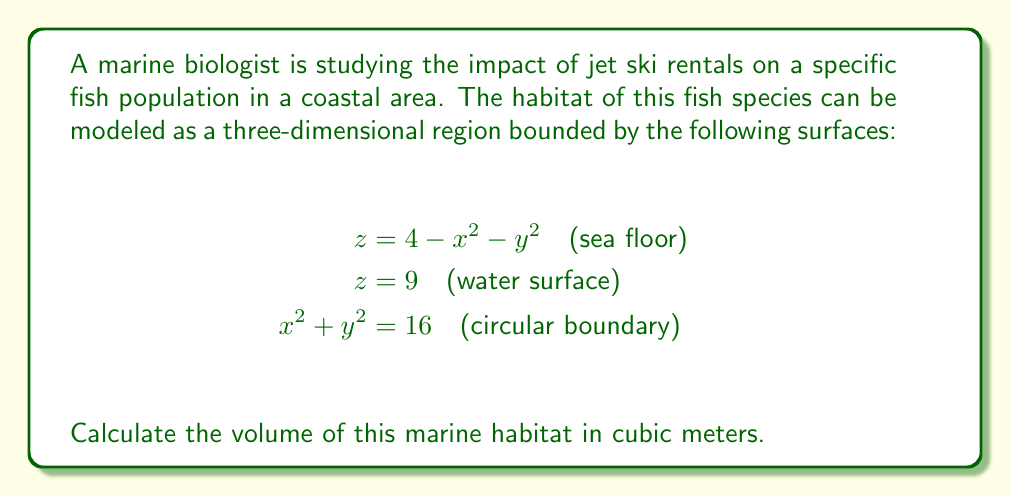Teach me how to tackle this problem. To determine the volume of this three-dimensional marine habitat, we need to set up and evaluate a triple integral. Let's approach this step-by-step:

1) First, we need to determine the limits of integration. From the given equations:
   - The habitat is bounded from below by $z = 4 - x^2 - y^2$ and from above by $z = 9$.
   - The circular boundary $x^2 + y^2 = 16$ suggests we should use cylindrical coordinates.

2) In cylindrical coordinates, we have:
   $x = r\cos\theta$, $y = r\sin\theta$, $z = z$
   The circular boundary becomes: $r = 4$

3) The volume integral in cylindrical coordinates is:
   $$V = \int_0^{2\pi} \int_0^4 \int_{4-r^2}^9 r \, dz \, dr \, d\theta$$

4) Let's evaluate the inner integral first:
   $$\int_{4-r^2}^9 r \, dz = r[z]_{4-r^2}^9 = r(9 - (4-r^2)) = r(5+r^2)$$

5) Now our double integral becomes:
   $$V = \int_0^{2\pi} \int_0^4 r(5+r^2) \, dr \, d\theta$$

6) Evaluate the $r$ integral:
   $$\int_0^4 r(5+r^2) \, dr = [\frac{5r^2}{2} + \frac{r^4}{4}]_0^4 = (40 + 64) - (0 + 0) = 104$$

7) Finally, integrate with respect to $\theta$:
   $$V = \int_0^{2\pi} 104 \, d\theta = 104[θ]_0^{2\pi} = 104(2\pi)$$

Therefore, the volume of the marine habitat is $208\pi$ cubic meters.
Answer: $208\pi$ cubic meters 